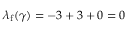<formula> <loc_0><loc_0><loc_500><loc_500>\lambda _ { f } ( \gamma ) = - 3 + 3 + 0 = 0</formula> 